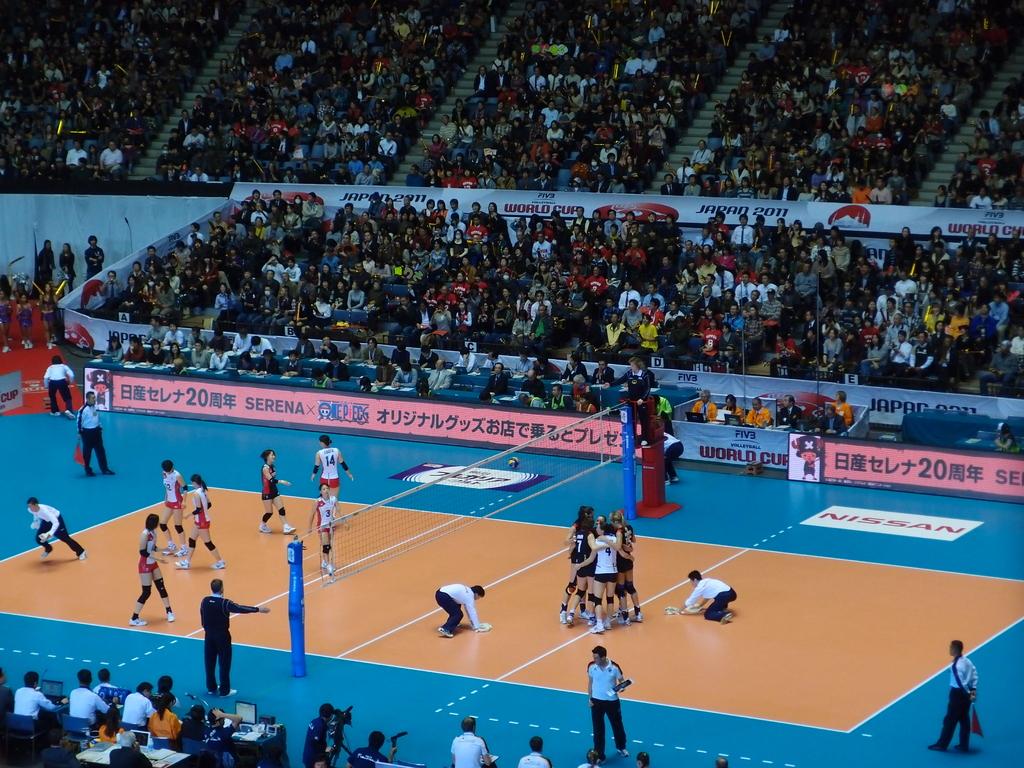What car sponsor is featured on the right of the court?
Provide a succinct answer. Nissan. 